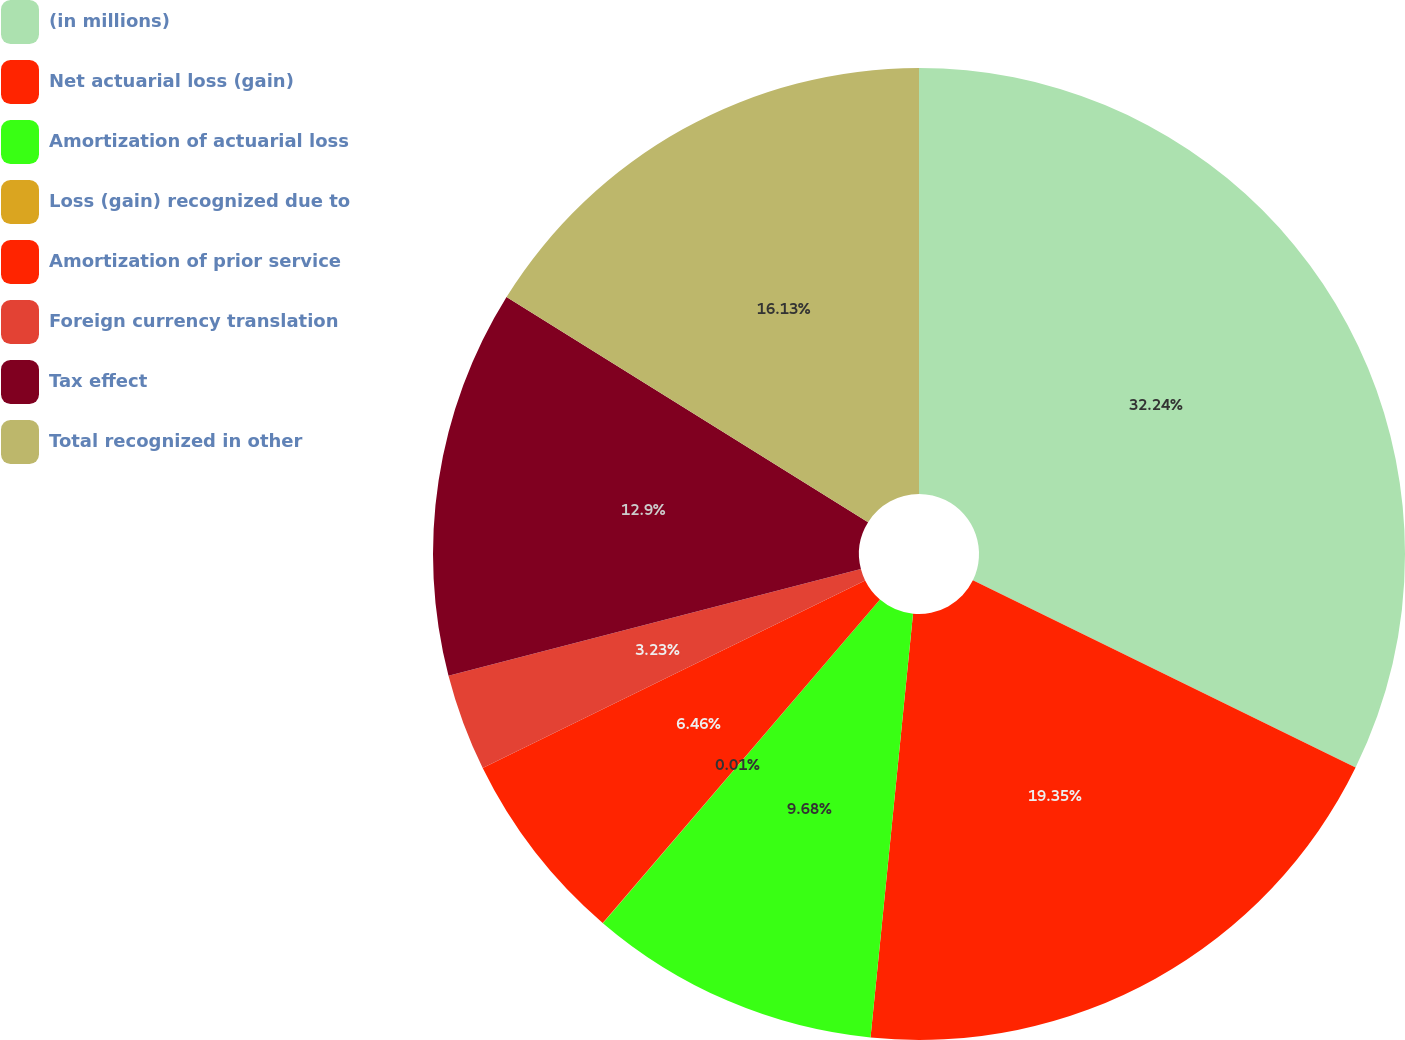Convert chart to OTSL. <chart><loc_0><loc_0><loc_500><loc_500><pie_chart><fcel>(in millions)<fcel>Net actuarial loss (gain)<fcel>Amortization of actuarial loss<fcel>Loss (gain) recognized due to<fcel>Amortization of prior service<fcel>Foreign currency translation<fcel>Tax effect<fcel>Total recognized in other<nl><fcel>32.24%<fcel>19.35%<fcel>9.68%<fcel>0.01%<fcel>6.46%<fcel>3.23%<fcel>12.9%<fcel>16.13%<nl></chart> 